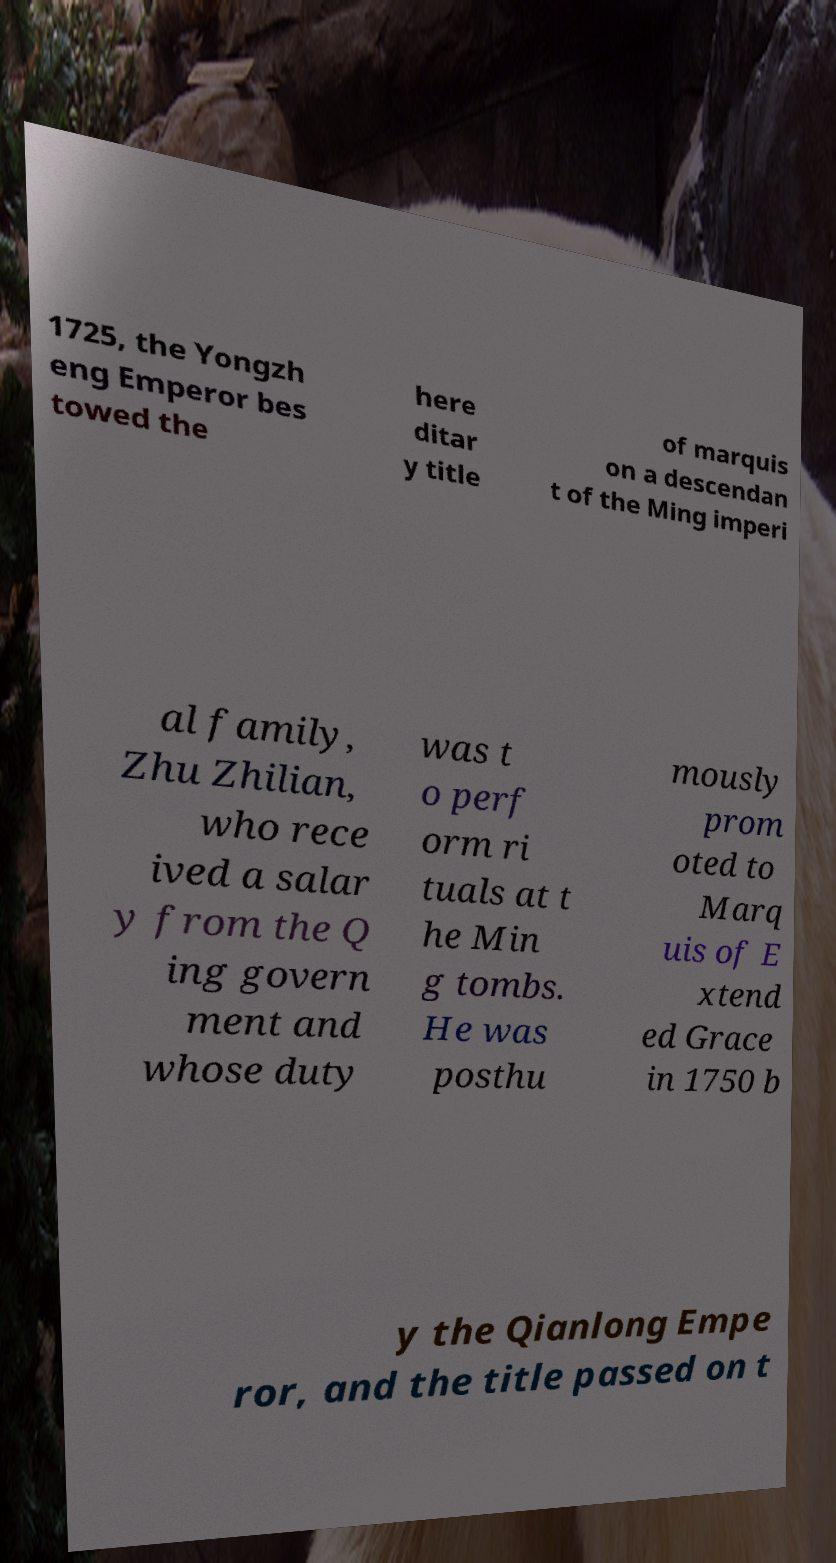Please identify and transcribe the text found in this image. 1725, the Yongzh eng Emperor bes towed the here ditar y title of marquis on a descendan t of the Ming imperi al family, Zhu Zhilian, who rece ived a salar y from the Q ing govern ment and whose duty was t o perf orm ri tuals at t he Min g tombs. He was posthu mously prom oted to Marq uis of E xtend ed Grace in 1750 b y the Qianlong Empe ror, and the title passed on t 